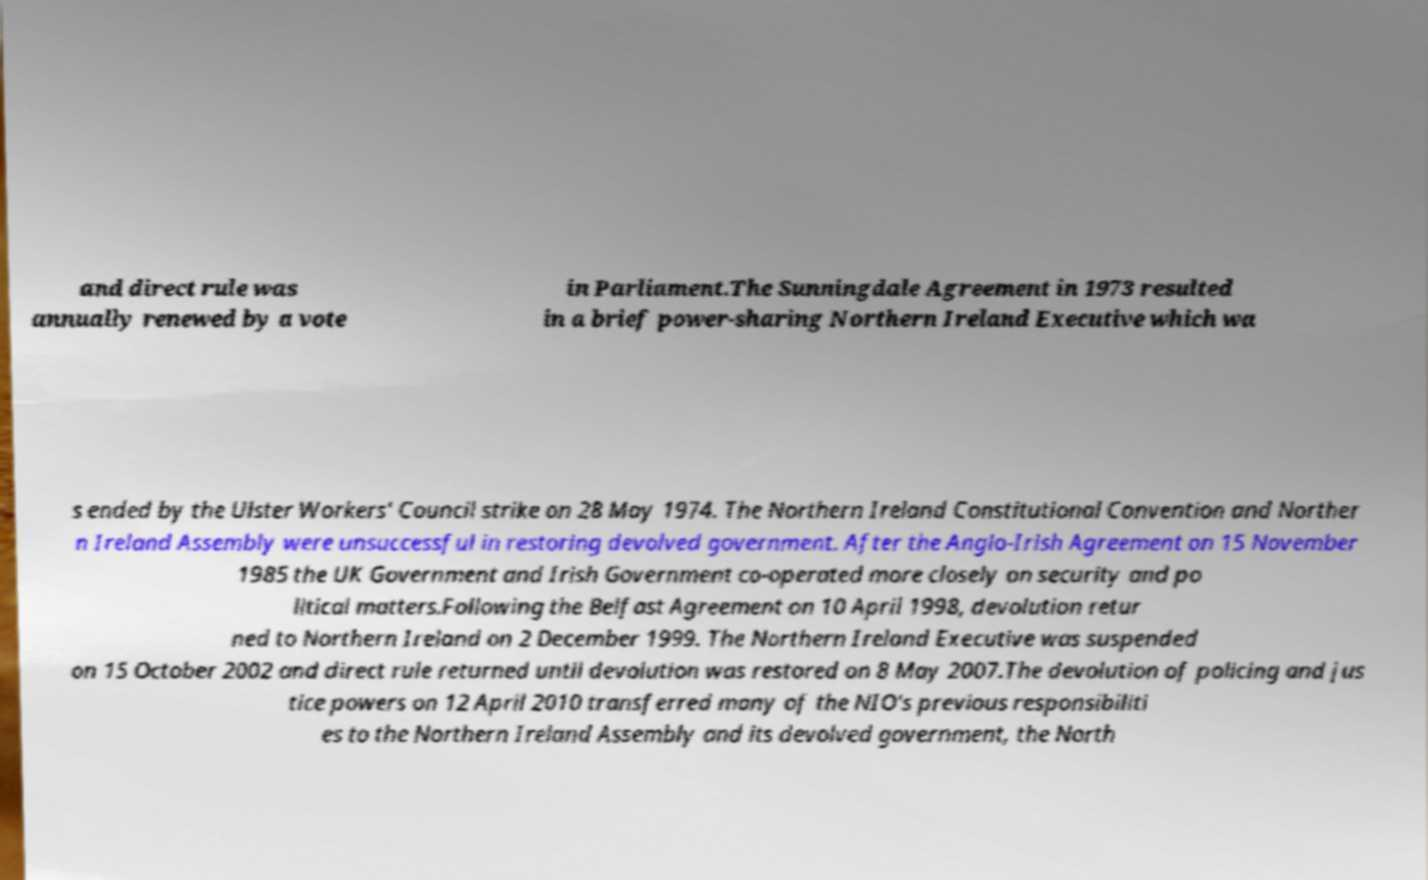There's text embedded in this image that I need extracted. Can you transcribe it verbatim? and direct rule was annually renewed by a vote in Parliament.The Sunningdale Agreement in 1973 resulted in a brief power-sharing Northern Ireland Executive which wa s ended by the Ulster Workers' Council strike on 28 May 1974. The Northern Ireland Constitutional Convention and Norther n Ireland Assembly were unsuccessful in restoring devolved government. After the Anglo-Irish Agreement on 15 November 1985 the UK Government and Irish Government co-operated more closely on security and po litical matters.Following the Belfast Agreement on 10 April 1998, devolution retur ned to Northern Ireland on 2 December 1999. The Northern Ireland Executive was suspended on 15 October 2002 and direct rule returned until devolution was restored on 8 May 2007.The devolution of policing and jus tice powers on 12 April 2010 transferred many of the NIO's previous responsibiliti es to the Northern Ireland Assembly and its devolved government, the North 